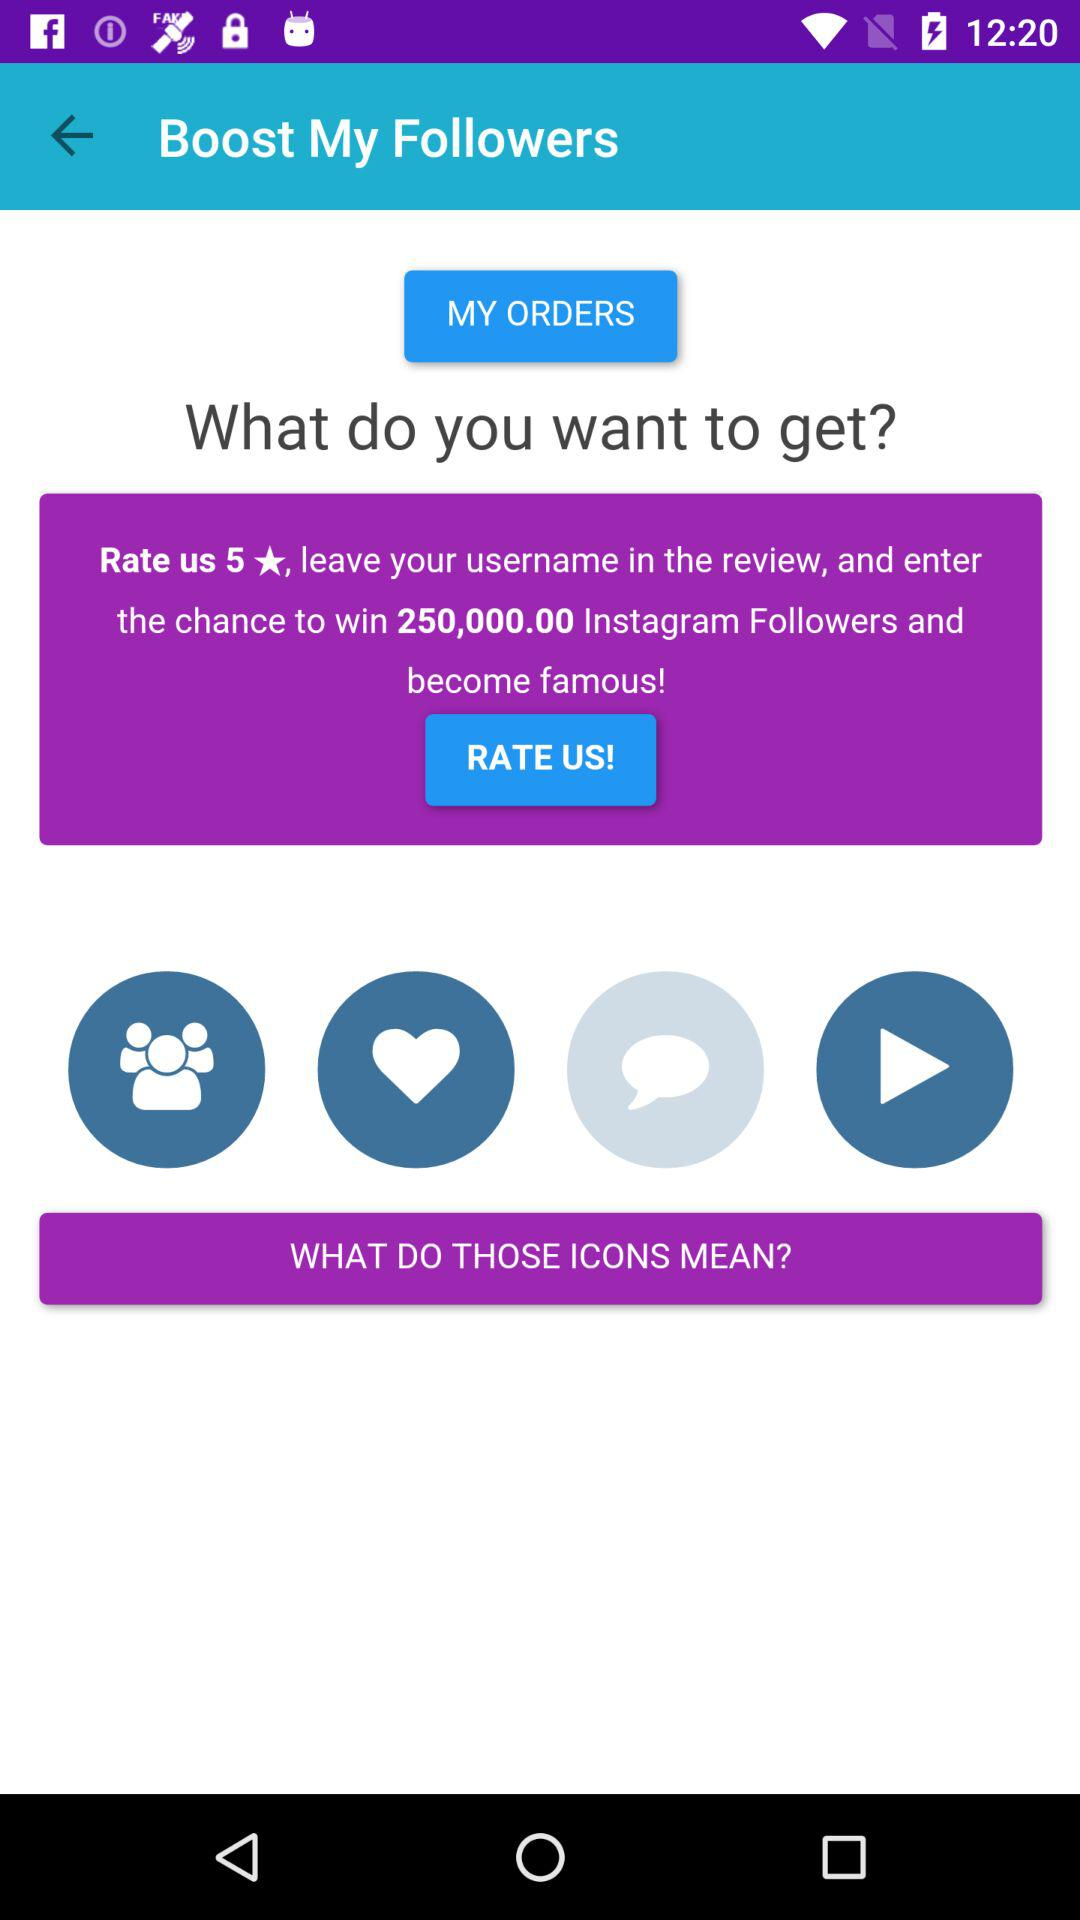How many followers can the user win? The user can win 250,000 followers. 